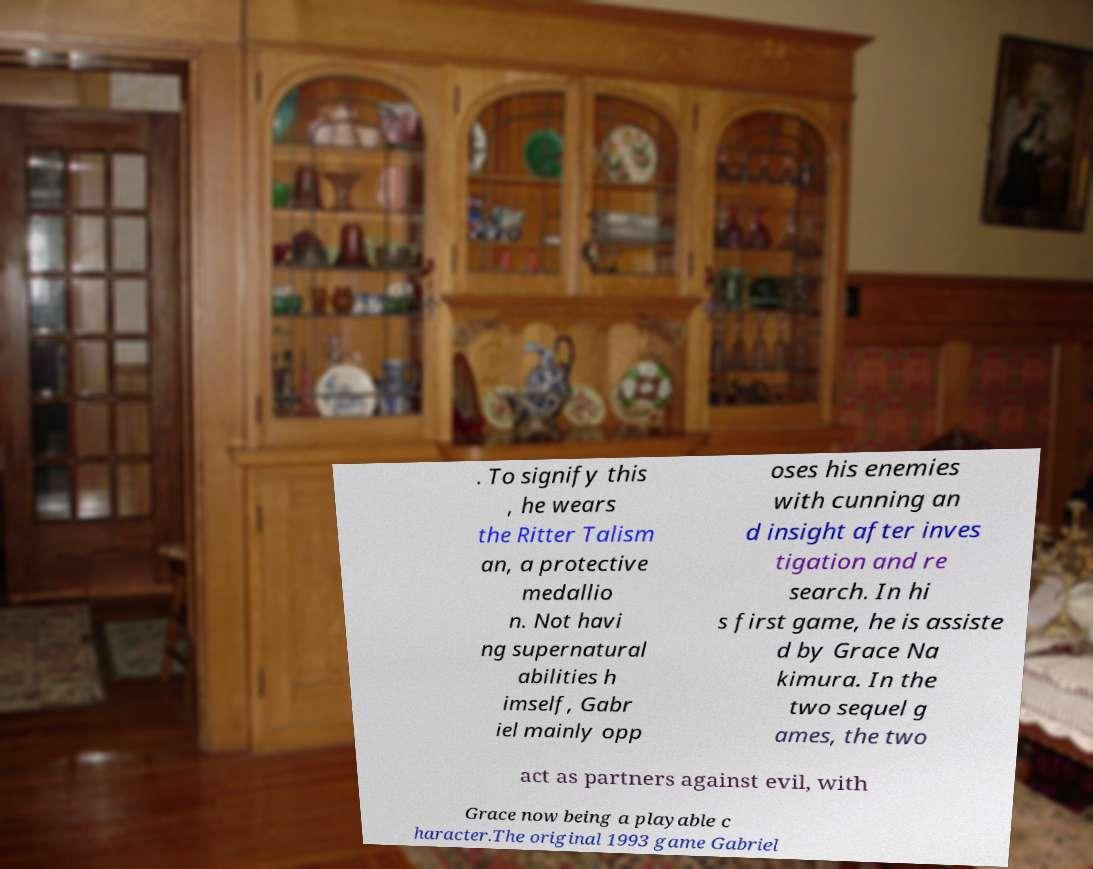Could you assist in decoding the text presented in this image and type it out clearly? . To signify this , he wears the Ritter Talism an, a protective medallio n. Not havi ng supernatural abilities h imself, Gabr iel mainly opp oses his enemies with cunning an d insight after inves tigation and re search. In hi s first game, he is assiste d by Grace Na kimura. In the two sequel g ames, the two act as partners against evil, with Grace now being a playable c haracter.The original 1993 game Gabriel 